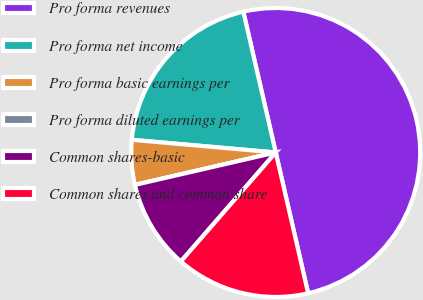<chart> <loc_0><loc_0><loc_500><loc_500><pie_chart><fcel>Pro forma revenues<fcel>Pro forma net income<fcel>Pro forma basic earnings per<fcel>Pro forma diluted earnings per<fcel>Common shares-basic<fcel>Common shares and common share<nl><fcel>50.0%<fcel>20.0%<fcel>5.0%<fcel>0.0%<fcel>10.0%<fcel>15.0%<nl></chart> 